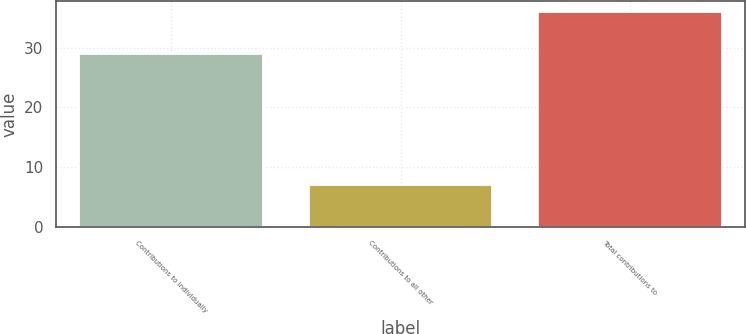<chart> <loc_0><loc_0><loc_500><loc_500><bar_chart><fcel>Contributions to individually<fcel>Contributions to all other<fcel>Total contributions to<nl><fcel>29<fcel>7<fcel>36<nl></chart> 